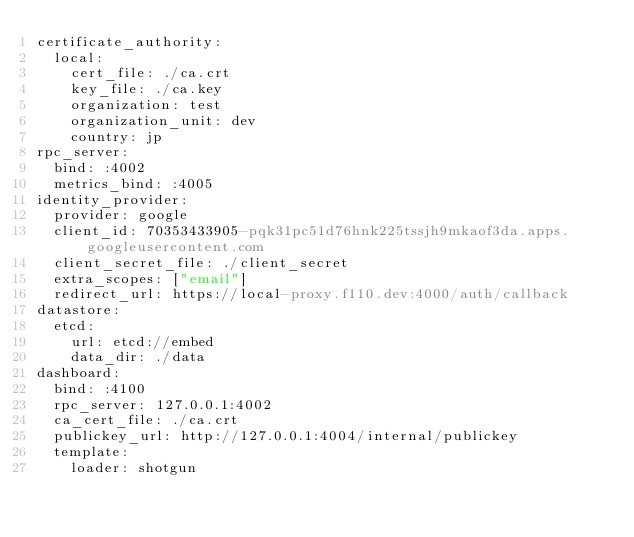Convert code to text. <code><loc_0><loc_0><loc_500><loc_500><_YAML_>certificate_authority:
  local:
    cert_file: ./ca.crt
    key_file: ./ca.key
    organization: test
    organization_unit: dev
    country: jp
rpc_server:
  bind: :4002
  metrics_bind: :4005
identity_provider:
  provider: google
  client_id: 70353433905-pqk31pc51d76hnk225tssjh9mkaof3da.apps.googleusercontent.com
  client_secret_file: ./client_secret
  extra_scopes: ["email"]
  redirect_url: https://local-proxy.f110.dev:4000/auth/callback
datastore:
  etcd:
    url: etcd://embed
    data_dir: ./data
dashboard:
  bind: :4100
  rpc_server: 127.0.0.1:4002
  ca_cert_file: ./ca.crt
  publickey_url: http://127.0.0.1:4004/internal/publickey
  template:
    loader: shotgun</code> 